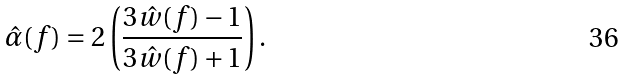<formula> <loc_0><loc_0><loc_500><loc_500>\hat { \alpha } ( f ) = 2 \left ( \frac { 3 \hat { w } ( f ) - 1 } { 3 \hat { w } ( f ) + 1 } \right ) .</formula> 